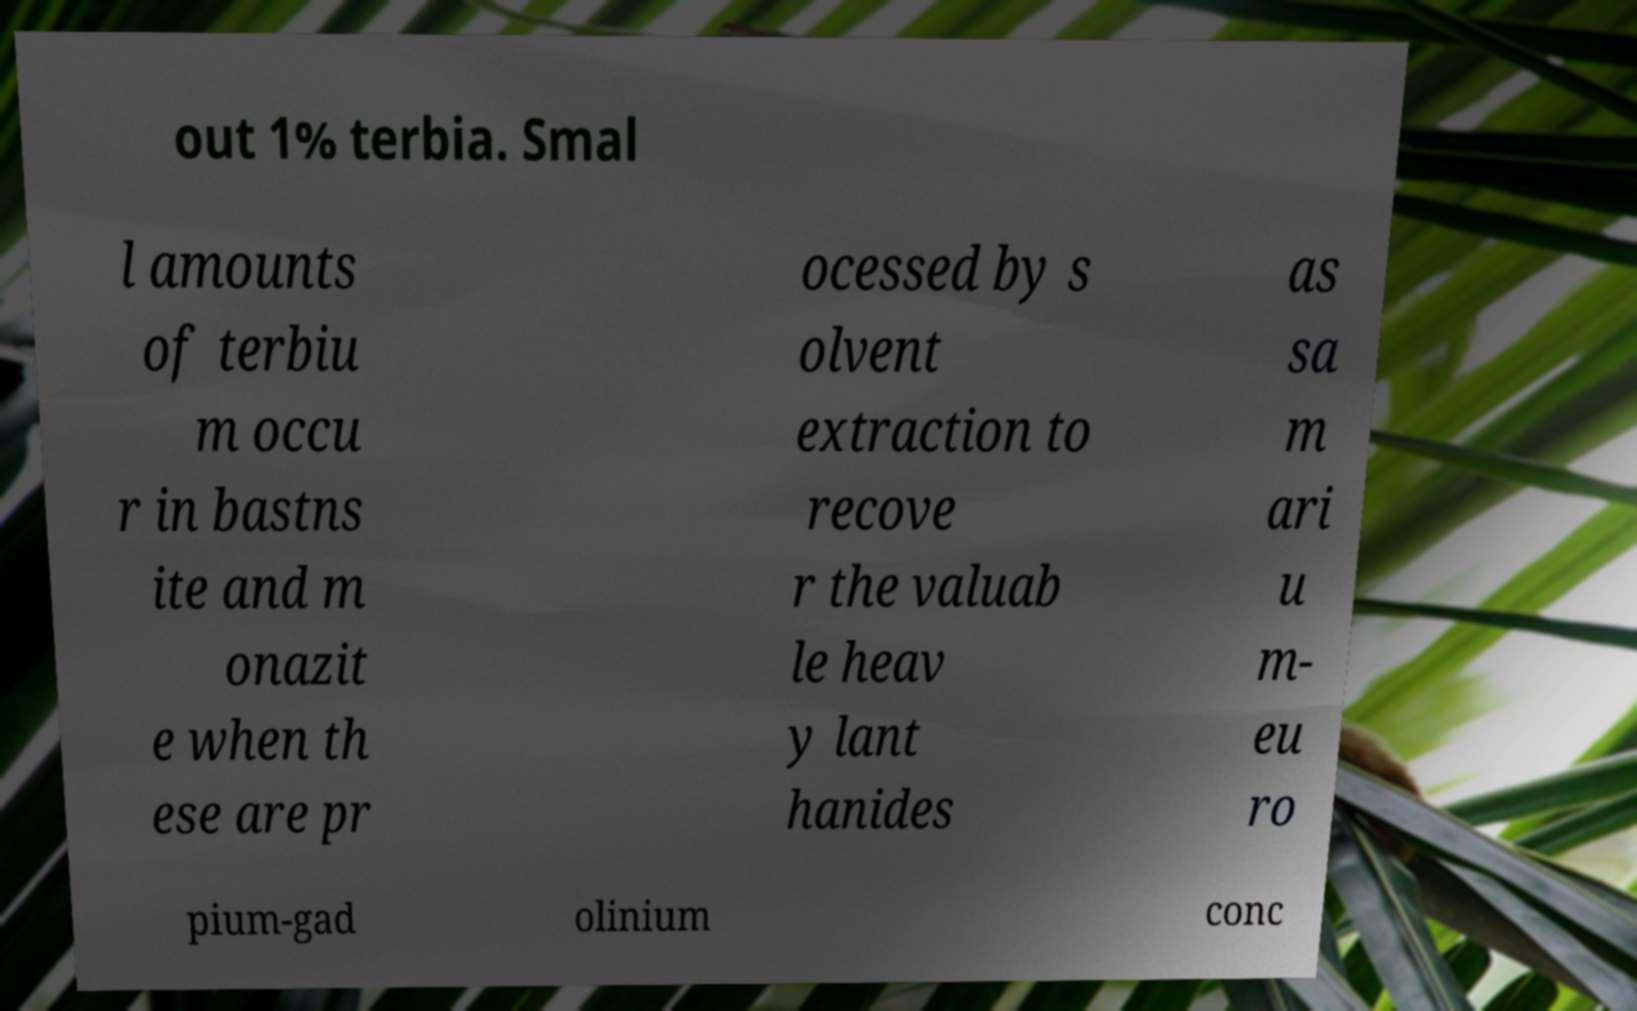For documentation purposes, I need the text within this image transcribed. Could you provide that? out 1% terbia. Smal l amounts of terbiu m occu r in bastns ite and m onazit e when th ese are pr ocessed by s olvent extraction to recove r the valuab le heav y lant hanides as sa m ari u m- eu ro pium-gad olinium conc 